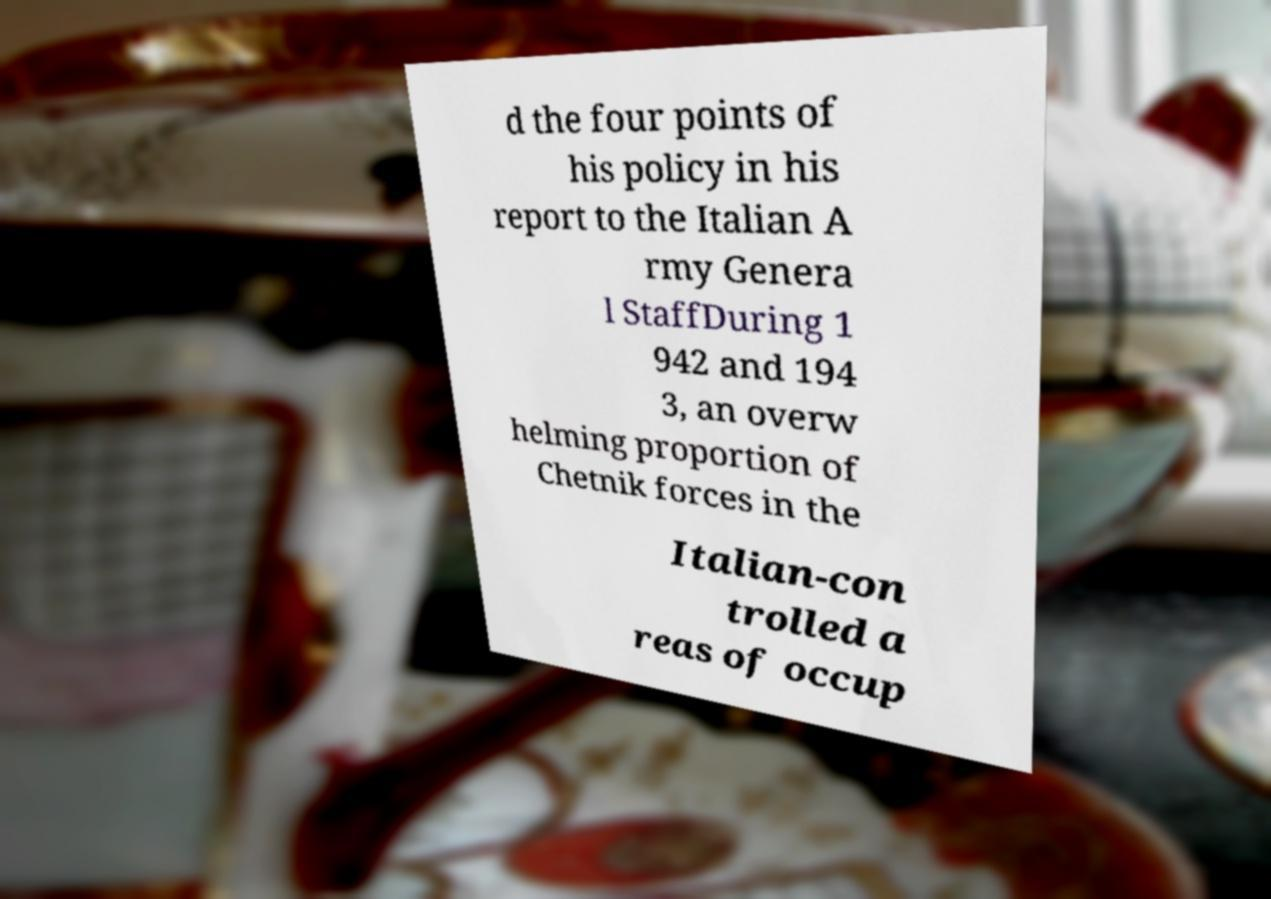I need the written content from this picture converted into text. Can you do that? d the four points of his policy in his report to the Italian A rmy Genera l StaffDuring 1 942 and 194 3, an overw helming proportion of Chetnik forces in the Italian-con trolled a reas of occup 